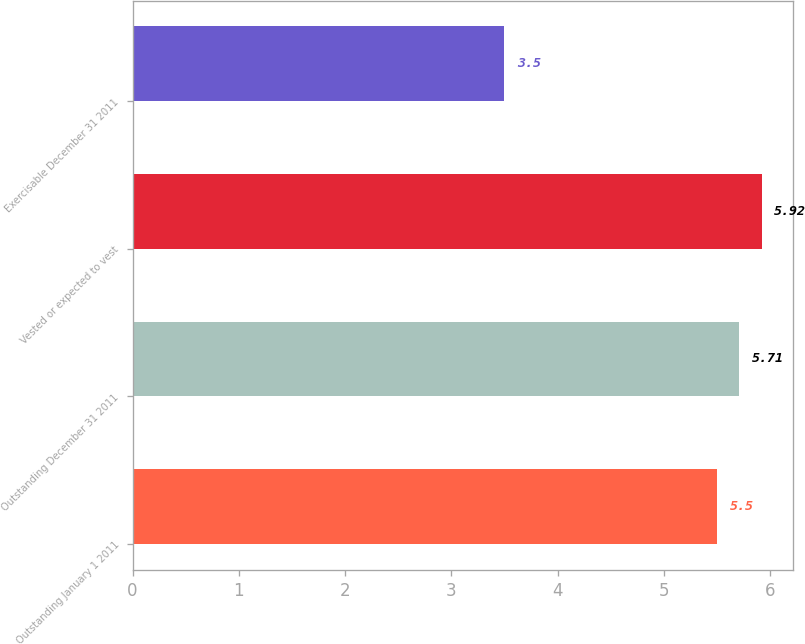<chart> <loc_0><loc_0><loc_500><loc_500><bar_chart><fcel>Outstanding January 1 2011<fcel>Outstanding December 31 2011<fcel>Vested or expected to vest<fcel>Exercisable December 31 2011<nl><fcel>5.5<fcel>5.71<fcel>5.92<fcel>3.5<nl></chart> 